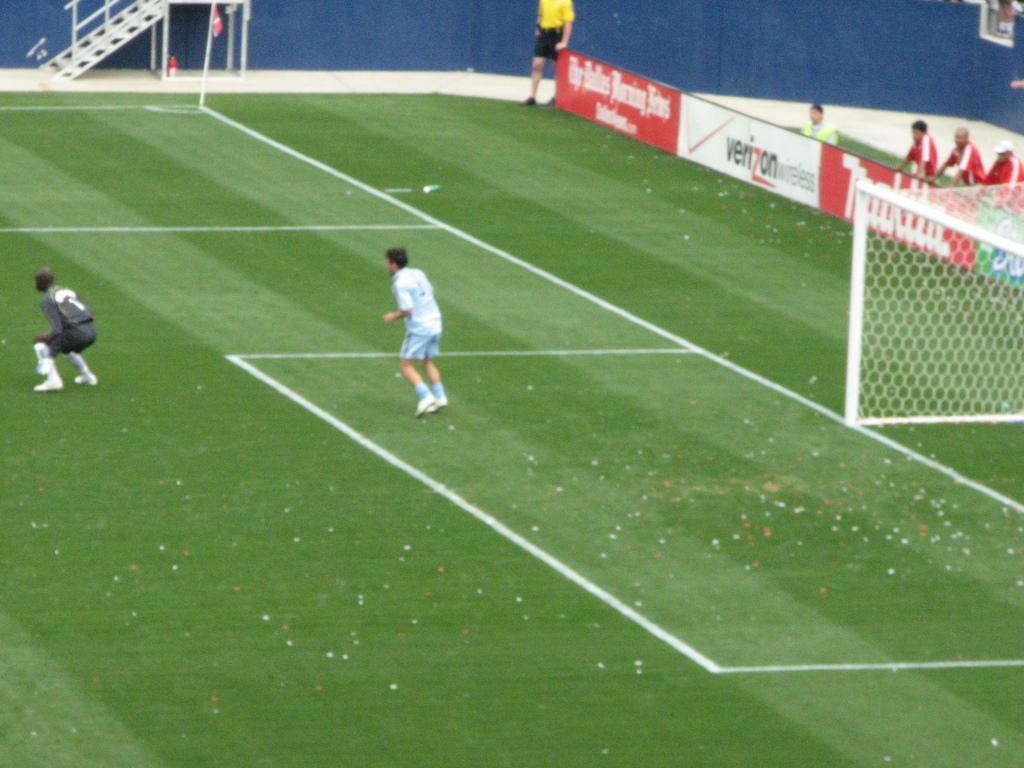Please provide a concise description of this image. On the left there is a person in squat position on the ground and behind him there is a person in motion. In the background there are few people standing on the ground at the hoarding,net,poles,flag on the ground,wall and some other items. 